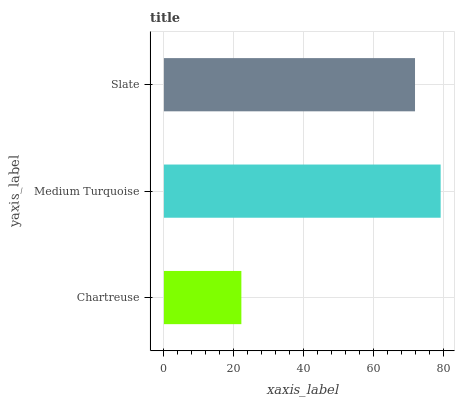Is Chartreuse the minimum?
Answer yes or no. Yes. Is Medium Turquoise the maximum?
Answer yes or no. Yes. Is Slate the minimum?
Answer yes or no. No. Is Slate the maximum?
Answer yes or no. No. Is Medium Turquoise greater than Slate?
Answer yes or no. Yes. Is Slate less than Medium Turquoise?
Answer yes or no. Yes. Is Slate greater than Medium Turquoise?
Answer yes or no. No. Is Medium Turquoise less than Slate?
Answer yes or no. No. Is Slate the high median?
Answer yes or no. Yes. Is Slate the low median?
Answer yes or no. Yes. Is Chartreuse the high median?
Answer yes or no. No. Is Medium Turquoise the low median?
Answer yes or no. No. 